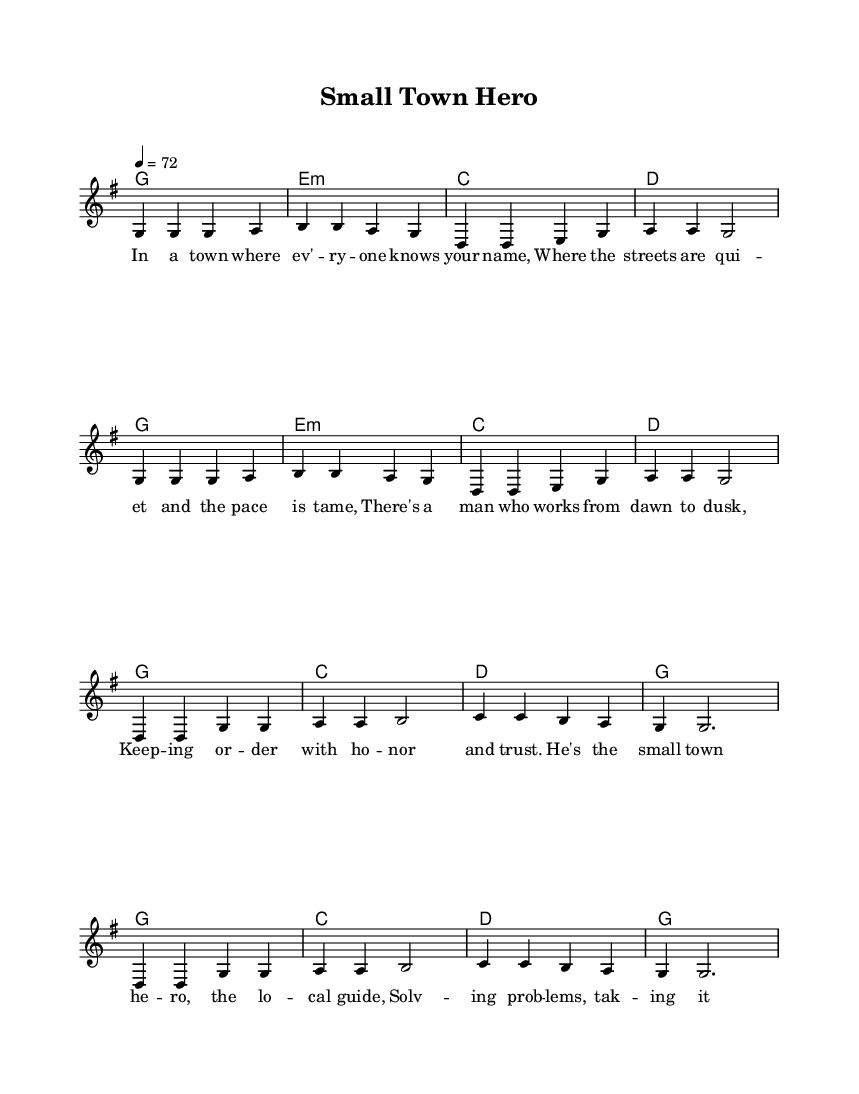What is the key signature of this music? The key signature shows that this piece is in G major, which has one sharp (F#). This is indicated at the beginning of the staff.
Answer: G major What is the time signature of this music? The time signature is indicated right after the key signature, showing 4/4, which means there are four beats in each measure and the quarter note gets one beat.
Answer: 4/4 What is the tempo marking for this piece? The tempo marking is indicated as 4 = 72, meaning there should be 72 beats per minute with the quarter note as the beat unit.
Answer: 72 How many measures are in the verse section? The verse has eight measures, as counted from the beginning of the melody part where the lyrics begin. Each four-line line corresponds to four measures.
Answer: 8 What is the primary theme of the lyrics? The lyrics describe a small-town mayor as a hero who maintains order and solves local problems, highlighting the governance aspect within a community context. The theme reflects local governance through the character of the mayor.
Answer: Local governance Which chord is repeated most frequently in the harmonies? The chord G major is used consistently in both the verse and chorus sections, appearing at the beginning of each section, indicating its importance in the harmony.
Answer: G major How does the song describe the town's atmosphere? The lyrics depict the town as having a quiet and tame pace, suggesting a peaceful and close-knit community environment which contrasts with urban hustle.
Answer: Peaceful and close-knit 